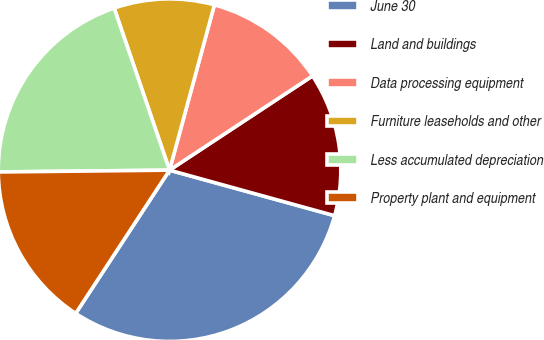Convert chart to OTSL. <chart><loc_0><loc_0><loc_500><loc_500><pie_chart><fcel>June 30<fcel>Land and buildings<fcel>Data processing equipment<fcel>Furniture leaseholds and other<fcel>Less accumulated depreciation<fcel>Property plant and equipment<nl><fcel>29.95%<fcel>13.56%<fcel>11.51%<fcel>9.46%<fcel>19.93%<fcel>15.6%<nl></chart> 